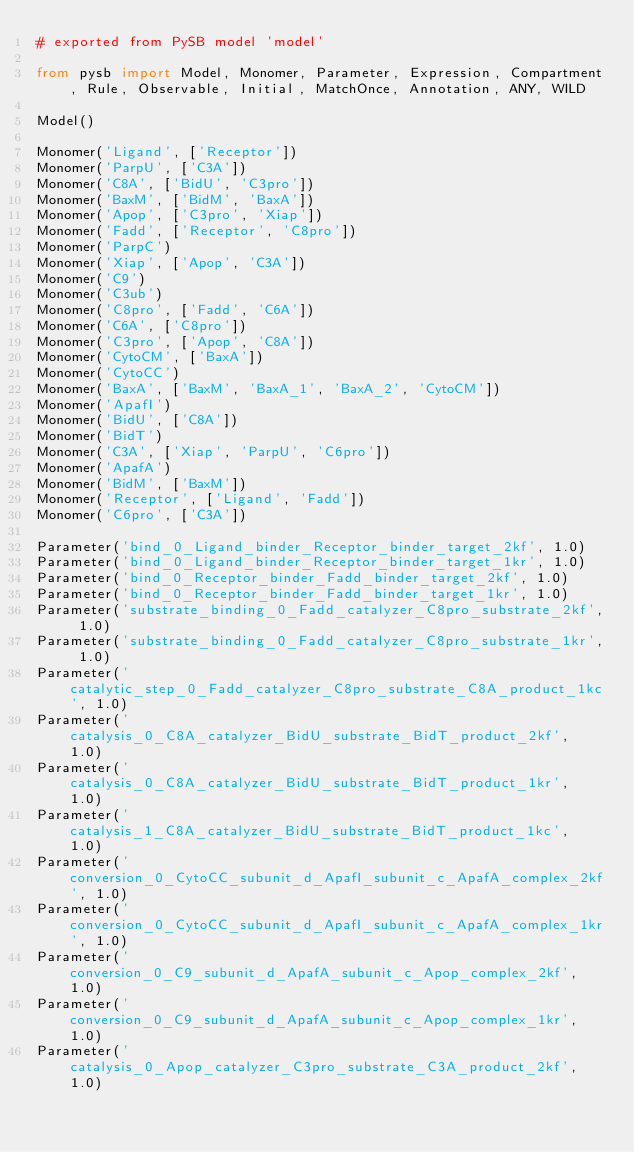Convert code to text. <code><loc_0><loc_0><loc_500><loc_500><_Python_># exported from PySB model 'model'

from pysb import Model, Monomer, Parameter, Expression, Compartment, Rule, Observable, Initial, MatchOnce, Annotation, ANY, WILD

Model()

Monomer('Ligand', ['Receptor'])
Monomer('ParpU', ['C3A'])
Monomer('C8A', ['BidU', 'C3pro'])
Monomer('BaxM', ['BidM', 'BaxA'])
Monomer('Apop', ['C3pro', 'Xiap'])
Monomer('Fadd', ['Receptor', 'C8pro'])
Monomer('ParpC')
Monomer('Xiap', ['Apop', 'C3A'])
Monomer('C9')
Monomer('C3ub')
Monomer('C8pro', ['Fadd', 'C6A'])
Monomer('C6A', ['C8pro'])
Monomer('C3pro', ['Apop', 'C8A'])
Monomer('CytoCM', ['BaxA'])
Monomer('CytoCC')
Monomer('BaxA', ['BaxM', 'BaxA_1', 'BaxA_2', 'CytoCM'])
Monomer('ApafI')
Monomer('BidU', ['C8A'])
Monomer('BidT')
Monomer('C3A', ['Xiap', 'ParpU', 'C6pro'])
Monomer('ApafA')
Monomer('BidM', ['BaxM'])
Monomer('Receptor', ['Ligand', 'Fadd'])
Monomer('C6pro', ['C3A'])

Parameter('bind_0_Ligand_binder_Receptor_binder_target_2kf', 1.0)
Parameter('bind_0_Ligand_binder_Receptor_binder_target_1kr', 1.0)
Parameter('bind_0_Receptor_binder_Fadd_binder_target_2kf', 1.0)
Parameter('bind_0_Receptor_binder_Fadd_binder_target_1kr', 1.0)
Parameter('substrate_binding_0_Fadd_catalyzer_C8pro_substrate_2kf', 1.0)
Parameter('substrate_binding_0_Fadd_catalyzer_C8pro_substrate_1kr', 1.0)
Parameter('catalytic_step_0_Fadd_catalyzer_C8pro_substrate_C8A_product_1kc', 1.0)
Parameter('catalysis_0_C8A_catalyzer_BidU_substrate_BidT_product_2kf', 1.0)
Parameter('catalysis_0_C8A_catalyzer_BidU_substrate_BidT_product_1kr', 1.0)
Parameter('catalysis_1_C8A_catalyzer_BidU_substrate_BidT_product_1kc', 1.0)
Parameter('conversion_0_CytoCC_subunit_d_ApafI_subunit_c_ApafA_complex_2kf', 1.0)
Parameter('conversion_0_CytoCC_subunit_d_ApafI_subunit_c_ApafA_complex_1kr', 1.0)
Parameter('conversion_0_C9_subunit_d_ApafA_subunit_c_Apop_complex_2kf', 1.0)
Parameter('conversion_0_C9_subunit_d_ApafA_subunit_c_Apop_complex_1kr', 1.0)
Parameter('catalysis_0_Apop_catalyzer_C3pro_substrate_C3A_product_2kf', 1.0)</code> 